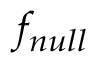<formula> <loc_0><loc_0><loc_500><loc_500>f _ { n u l l }</formula> 